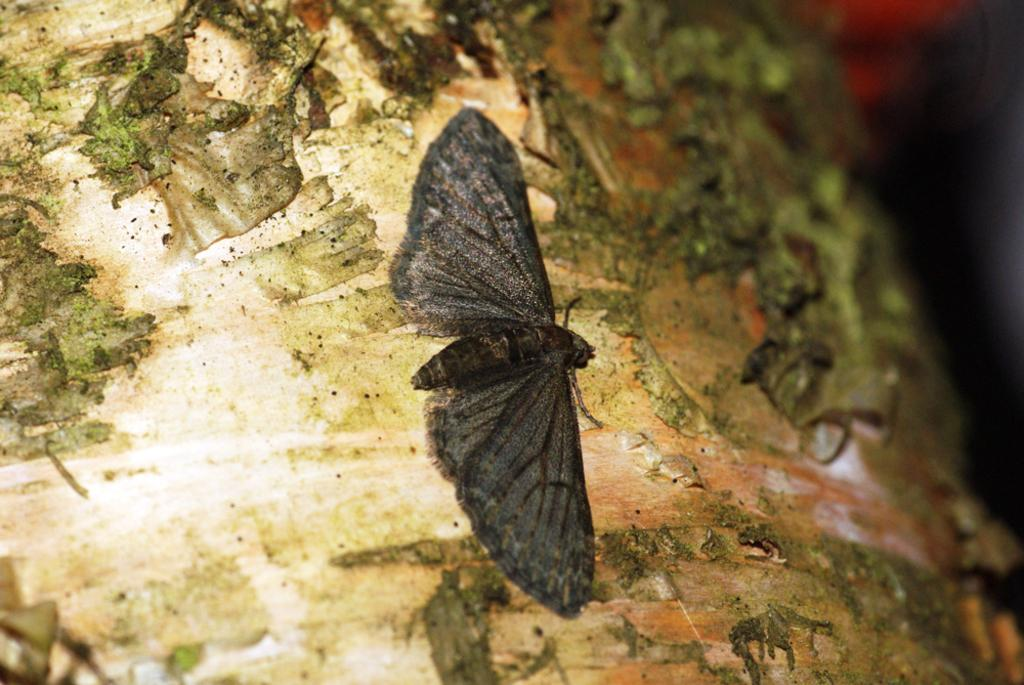What type of insect is in the image? There is a black color butterfly in the image. What is the butterfly doing in the image? The butterfly is laying on a surface. Can you describe the colors of the surface the butterfly is on? The surface has white and green colors. What does the caption say about the butterfly in the image? There is no caption present in the image, so it cannot be determined what it might say about the butterfly. 